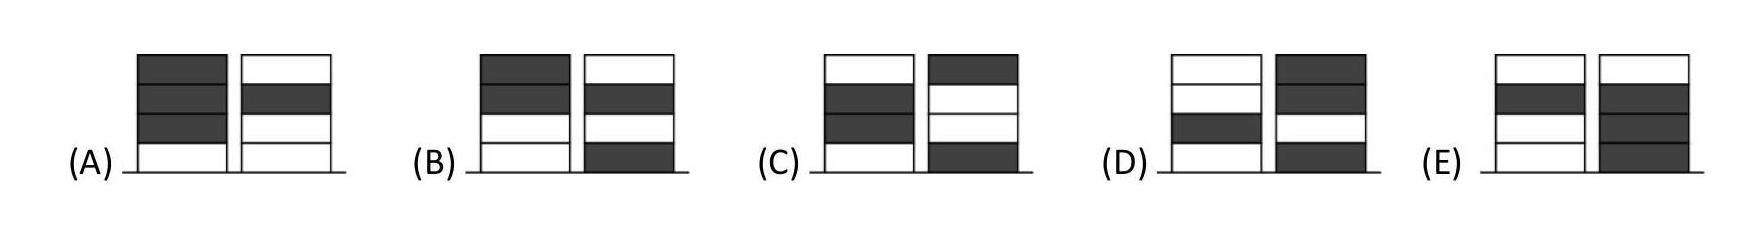Can you describe a strategy that Ronja could use to force more of her tokens into one pile? Ronja could place her initial two tokens in the same pile during her first and second turns, compelling Wanja to react defensively. Depending on Wanja's placements, Ronja could continue to focus her remaining tokens predominantly in one pile, potentially leading to an uneven distribution if not countered by Wanja. 